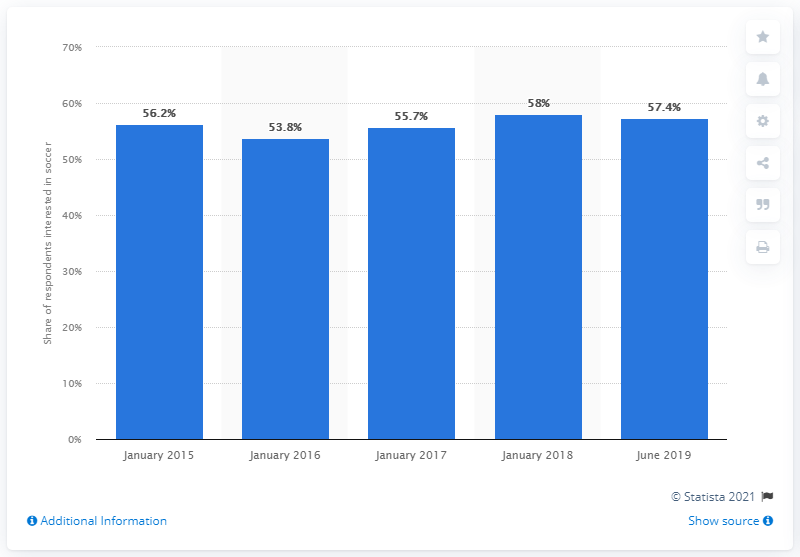Give some essential details in this illustration. The survey revealed that 57.4% of the participants preferred to watch, play or stay informed about soccer. 